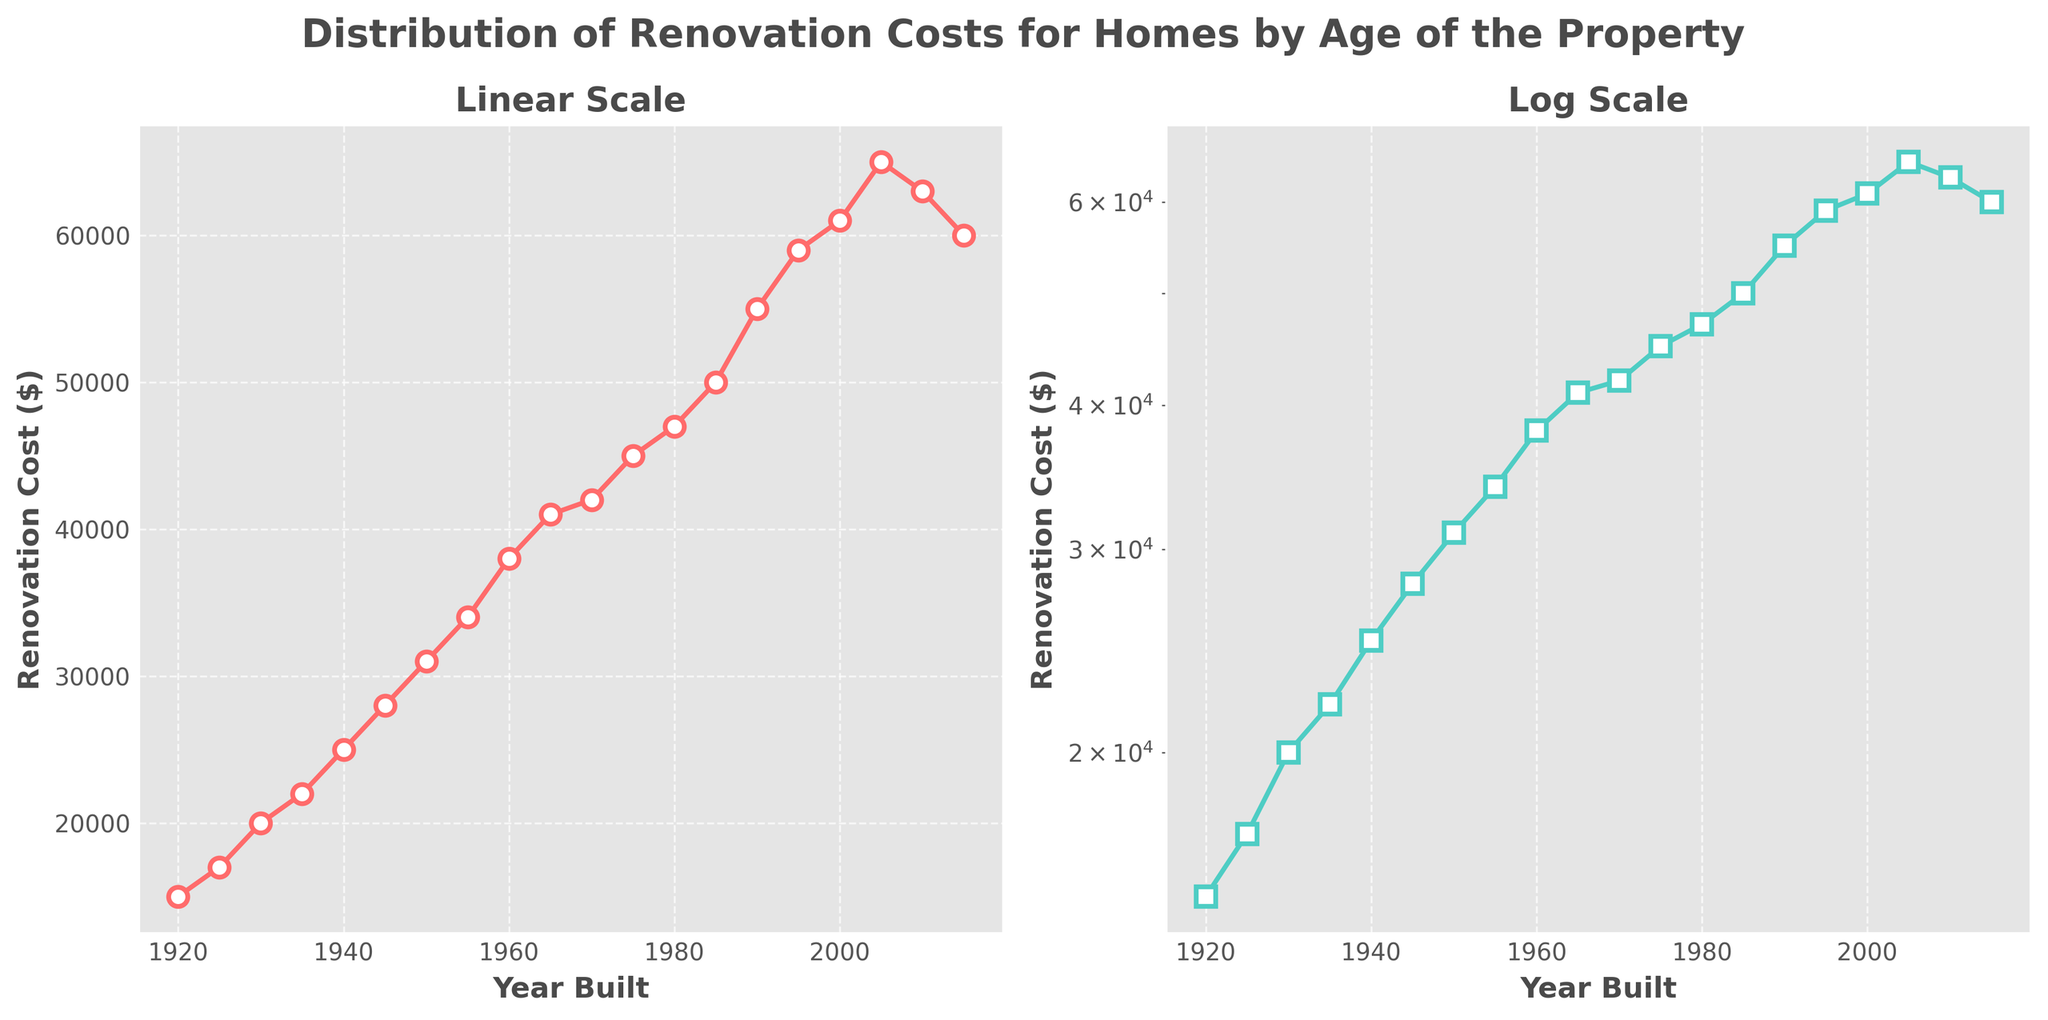What's the title of the figure? The title is prominently displayed at the top of the figure. It reads "Distribution of Renovation Costs for Homes by Age of the Property".
Answer: Distribution of Renovation Costs for Homes by Age of the Property How are the colors of the lines different in the two subplots? The left subplot uses a line colored in red (with markers), while the right subplot uses a green line (with markers).
Answer: Red (left) and Green (right) What is the highest Renovation Cost in the linear scale plot and its corresponding Year Built? In the linear scale plot (left), the highest renovation cost is $65,000, which corresponds to the year 2005.
Answer: $65,000 in 2005 How does the Renovation Cost trend differ between the linear and log scale plots? The linear scale plot shows the costs increasing linearly, while the log scale plot indicates a more exponential growth. This suggests that the costs rise more sharply in more recent years when viewed on a log scale.
Answer: Linear vs. Exponential Growth What can be inferred about renovation costs post-2000 from the log scale plot? The log scale plot reveals a slight decline in renovation costs post-2000, despite a previous sharp increase. This suggests a potential leveling or decrease in renovation investments after 2000.
Answer: Slight decline Which year shows the smallest increase in Renovation Cost within a 10-year span on the linear scale plot? Examining the linear scale plot within each decade, from 2010 to 2015, the increase is just $3,000, the smallest increment seen.
Answer: 2010 to 2015 In which year is the renovation cost around $50,000 in the logarithmic scale plot? Referencing the log scale plot, around the year 1985, the renovation cost approximately reaches $50,000.
Answer: 1985 What is the overall trend in renovation costs from 1920 to 2015? Both subplots reveal a general upward trend in renovation costs from 1920 to 2015. After a peak around 2005, there's a slight reduction towards 2015.
Answer: Increasing trend with a slight reduction post-2005 If the renovation cost doubles every decade, what should be the cost in 1960 if it was $15,000 in 1920? Doubling every decade would result in: 1920 - $15,000, 1930 - $30,000, 1940 - $60,000, 1950 - $120,000, 1960 - $240,000. Therefore, the cost should be $240,000.
Answer: $240,000 